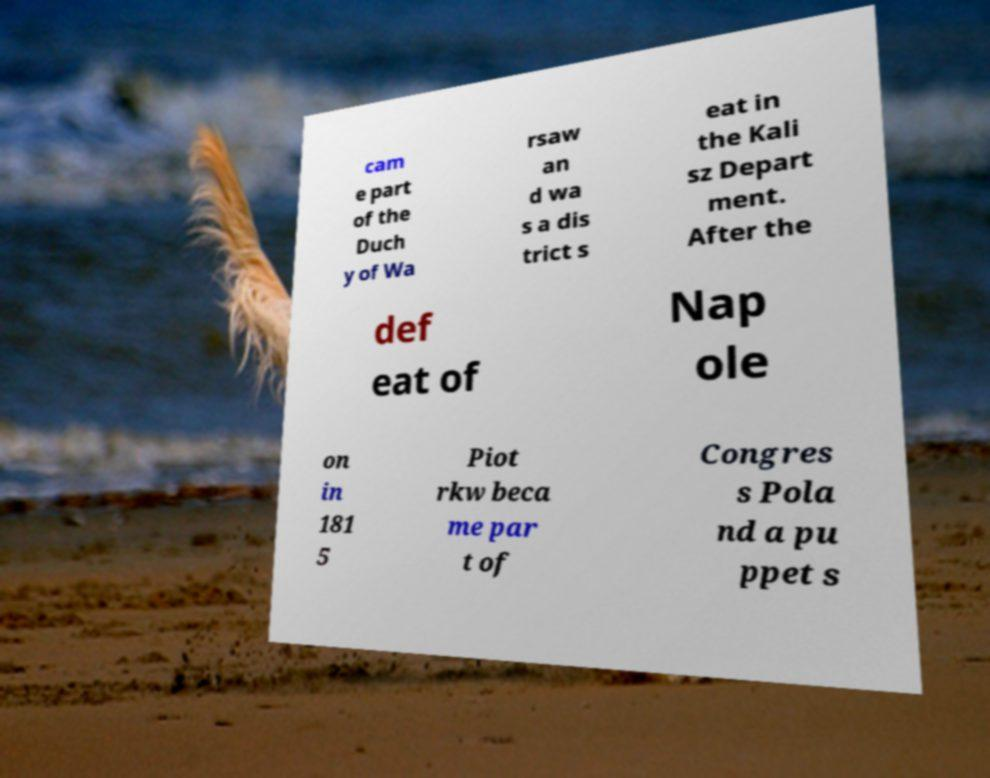Could you extract and type out the text from this image? cam e part of the Duch y of Wa rsaw an d wa s a dis trict s eat in the Kali sz Depart ment. After the def eat of Nap ole on in 181 5 Piot rkw beca me par t of Congres s Pola nd a pu ppet s 